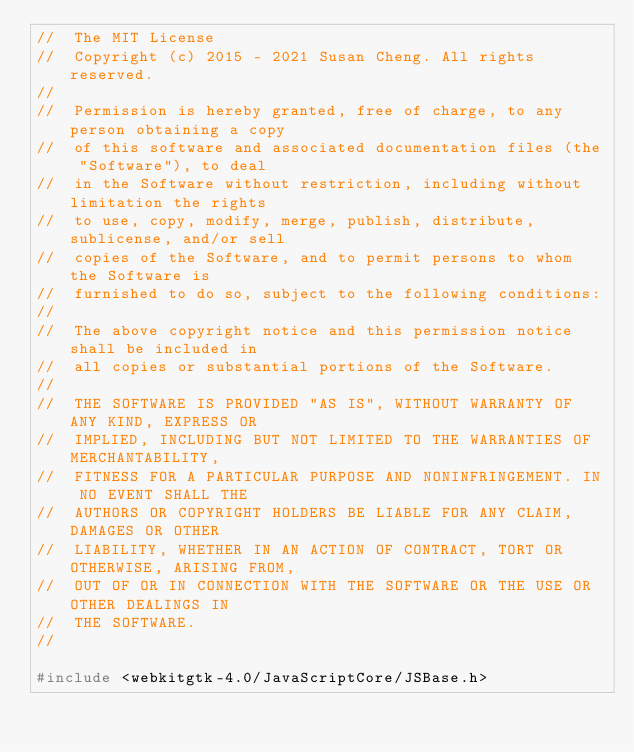<code> <loc_0><loc_0><loc_500><loc_500><_C_>//  The MIT License
//  Copyright (c) 2015 - 2021 Susan Cheng. All rights reserved.
//
//  Permission is hereby granted, free of charge, to any person obtaining a copy
//  of this software and associated documentation files (the "Software"), to deal
//  in the Software without restriction, including without limitation the rights
//  to use, copy, modify, merge, publish, distribute, sublicense, and/or sell
//  copies of the Software, and to permit persons to whom the Software is
//  furnished to do so, subject to the following conditions:
//
//  The above copyright notice and this permission notice shall be included in
//  all copies or substantial portions of the Software.
//
//  THE SOFTWARE IS PROVIDED "AS IS", WITHOUT WARRANTY OF ANY KIND, EXPRESS OR
//  IMPLIED, INCLUDING BUT NOT LIMITED TO THE WARRANTIES OF MERCHANTABILITY,
//  FITNESS FOR A PARTICULAR PURPOSE AND NONINFRINGEMENT. IN NO EVENT SHALL THE
//  AUTHORS OR COPYRIGHT HOLDERS BE LIABLE FOR ANY CLAIM, DAMAGES OR OTHER
//  LIABILITY, WHETHER IN AN ACTION OF CONTRACT, TORT OR OTHERWISE, ARISING FROM,
//  OUT OF OR IN CONNECTION WITH THE SOFTWARE OR THE USE OR OTHER DEALINGS IN
//  THE SOFTWARE.
//

#include <webkitgtk-4.0/JavaScriptCore/JSBase.h>
</code> 